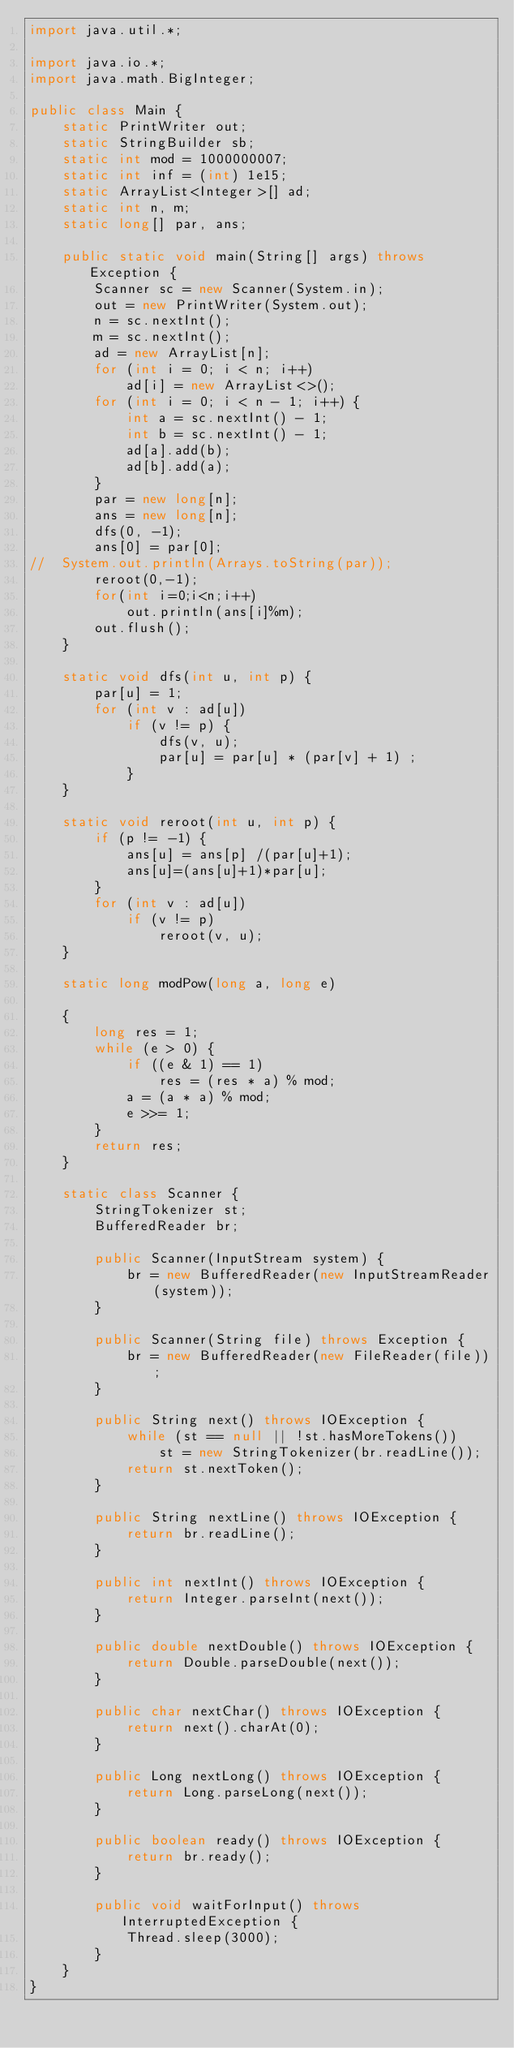Convert code to text. <code><loc_0><loc_0><loc_500><loc_500><_Java_>import java.util.*;

import java.io.*;
import java.math.BigInteger;

public class Main {
	static PrintWriter out;
	static StringBuilder sb;
	static int mod = 1000000007;
	static int inf = (int) 1e15;
	static ArrayList<Integer>[] ad;
	static int n, m;
	static long[] par, ans;

	public static void main(String[] args) throws Exception {
		Scanner sc = new Scanner(System.in);
		out = new PrintWriter(System.out);
		n = sc.nextInt();
		m = sc.nextInt();
		ad = new ArrayList[n];
		for (int i = 0; i < n; i++)
			ad[i] = new ArrayList<>();
		for (int i = 0; i < n - 1; i++) {
			int a = sc.nextInt() - 1;
			int b = sc.nextInt() - 1;
			ad[a].add(b);
			ad[b].add(a);
		}
		par = new long[n];
		ans = new long[n];
		dfs(0, -1);
		ans[0] = par[0];
//	System.out.println(Arrays.toString(par));
		reroot(0,-1);
		for(int i=0;i<n;i++)
			out.println(ans[i]%m);
		out.flush();
	}

	static void dfs(int u, int p) {
		par[u] = 1;
		for (int v : ad[u])
			if (v != p) {
				dfs(v, u);
				par[u] = par[u] * (par[v] + 1) ;
			}
	}

	static void reroot(int u, int p) {
		if (p != -1) {
			ans[u] = ans[p] /(par[u]+1);
			ans[u]=(ans[u]+1)*par[u];
		}
		for (int v : ad[u])
			if (v != p)
				reroot(v, u);
	}

	static long modPow(long a, long e)

	{
		long res = 1;
		while (e > 0) {
			if ((e & 1) == 1)
				res = (res * a) % mod;
			a = (a * a) % mod;
			e >>= 1;
		}
		return res;
	}

	static class Scanner {
		StringTokenizer st;
		BufferedReader br;

		public Scanner(InputStream system) {
			br = new BufferedReader(new InputStreamReader(system));
		}

		public Scanner(String file) throws Exception {
			br = new BufferedReader(new FileReader(file));
		}

		public String next() throws IOException {
			while (st == null || !st.hasMoreTokens())
				st = new StringTokenizer(br.readLine());
			return st.nextToken();
		}

		public String nextLine() throws IOException {
			return br.readLine();
		}

		public int nextInt() throws IOException {
			return Integer.parseInt(next());
		}

		public double nextDouble() throws IOException {
			return Double.parseDouble(next());
		}

		public char nextChar() throws IOException {
			return next().charAt(0);
		}

		public Long nextLong() throws IOException {
			return Long.parseLong(next());
		}

		public boolean ready() throws IOException {
			return br.ready();
		}

		public void waitForInput() throws InterruptedException {
			Thread.sleep(3000);
		}
	}
}</code> 